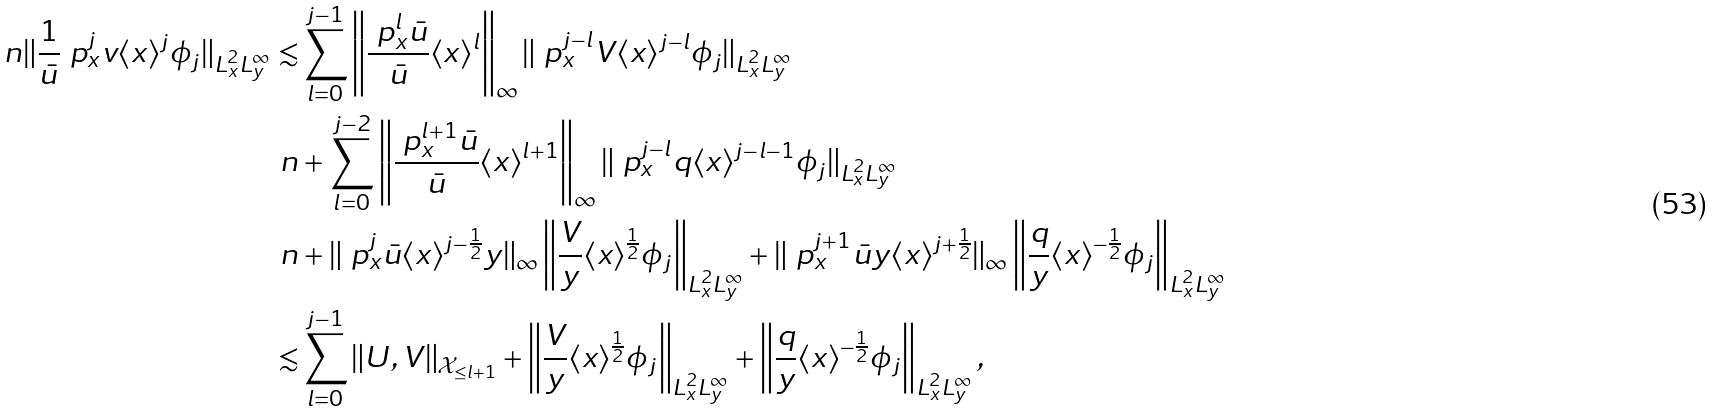Convert formula to latex. <formula><loc_0><loc_0><loc_500><loc_500>\ n \| \frac { 1 } { \bar { u } } \ p _ { x } ^ { j } v \langle x \rangle ^ { j } \phi _ { j } \| _ { L ^ { 2 } _ { x } L ^ { \infty } _ { y } } \lesssim & \sum _ { l = 0 } ^ { j - 1 } \left \| \frac { \ p _ { x } ^ { l } \bar { u } } { \bar { u } } \langle x \rangle ^ { l } \right \| _ { \infty } \| \ p _ { x } ^ { j - l } V \langle x \rangle ^ { j - l } \phi _ { j } \| _ { L ^ { 2 } _ { x } L ^ { \infty } _ { y } } \\ \ n & + \sum _ { l = 0 } ^ { j - 2 } \left \| \frac { \ p _ { x } ^ { l + 1 } \bar { u } } { \bar { u } } \langle x \rangle ^ { l + 1 } \right \| _ { \infty } \| \ p _ { x } ^ { j - l } q \langle x \rangle ^ { j - l - 1 } \phi _ { j } \| _ { L ^ { 2 } _ { x } L ^ { \infty } _ { y } } \\ \ n & + \| \ p _ { x } ^ { j } \bar { u } \langle x \rangle ^ { j - \frac { 1 } { 2 } } y \| _ { \infty } \left \| \frac { V } { y } \langle x \rangle ^ { \frac { 1 } { 2 } } \phi _ { j } \right \| _ { L ^ { 2 } _ { x } L ^ { \infty } _ { y } } + \| \ p _ { x } ^ { j + 1 } \bar { u } y \langle x \rangle ^ { j + \frac { 1 } { 2 } } \| _ { \infty } \left \| \frac { q } { y } \langle x \rangle ^ { - \frac { 1 } { 2 } } \phi _ { j } \right \| _ { L ^ { 2 } _ { x } L ^ { \infty } _ { y } } \\ \lesssim & \sum _ { l = 0 } ^ { j - 1 } \| U , V \| _ { \mathcal { X } _ { \leq l + 1 } } + \left \| \frac { V } { y } \langle x \rangle ^ { \frac { 1 } { 2 } } \phi _ { j } \right \| _ { L ^ { 2 } _ { x } L ^ { \infty } _ { y } } + \left \| \frac { q } { y } \langle x \rangle ^ { - \frac { 1 } { 2 } } \phi _ { j } \right \| _ { L ^ { 2 } _ { x } L ^ { \infty } _ { y } } ,</formula> 